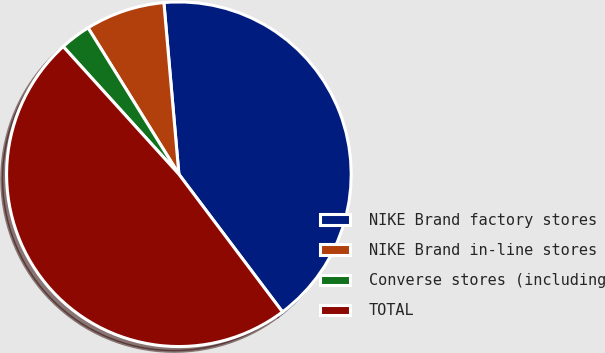Convert chart. <chart><loc_0><loc_0><loc_500><loc_500><pie_chart><fcel>NIKE Brand factory stores<fcel>NIKE Brand in-line stores<fcel>Converse stores (including<fcel>TOTAL<nl><fcel>41.12%<fcel>7.45%<fcel>2.88%<fcel>48.55%<nl></chart> 